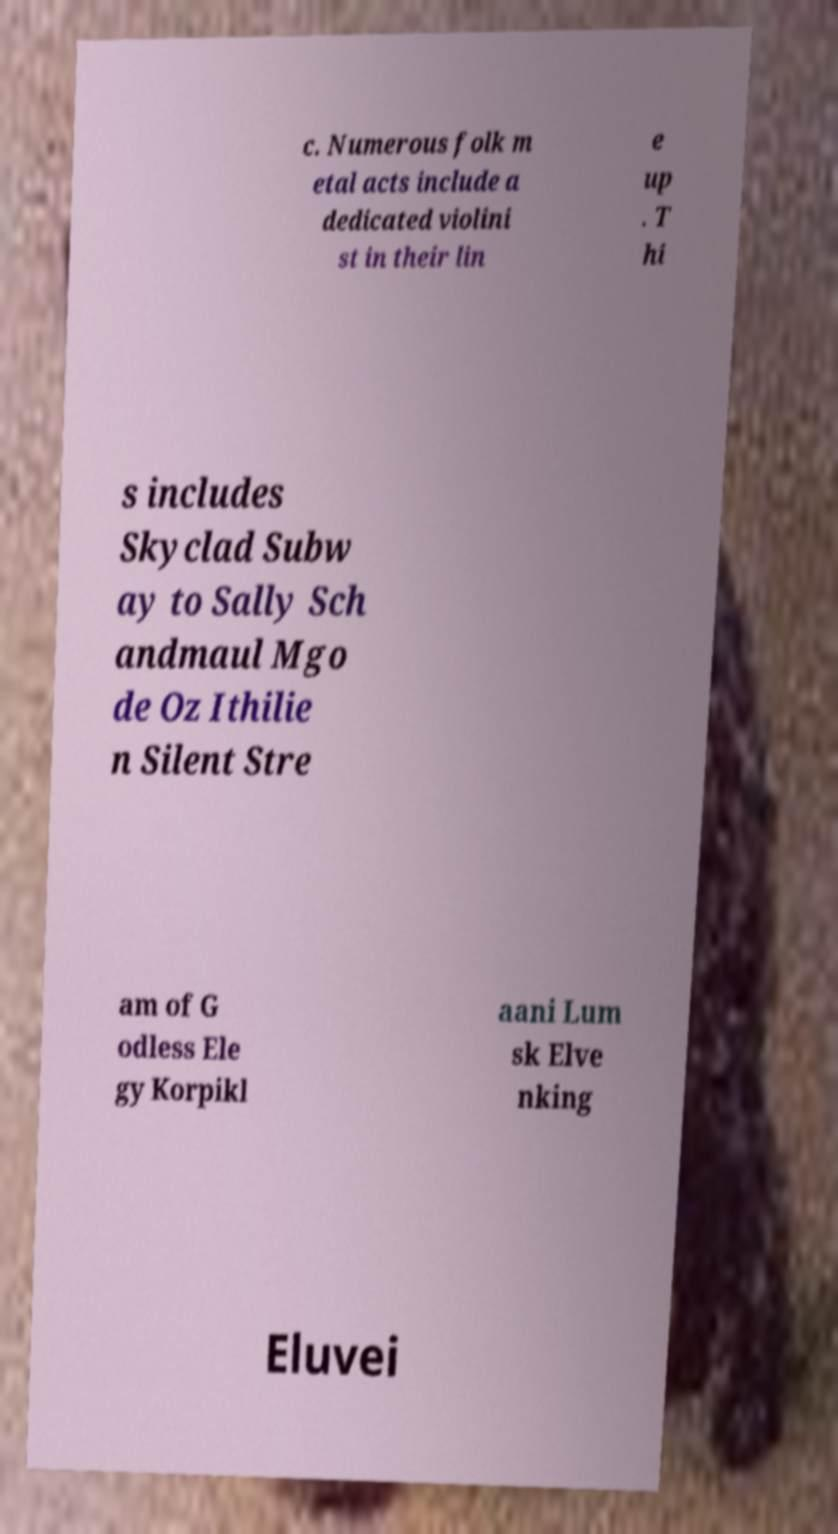I need the written content from this picture converted into text. Can you do that? c. Numerous folk m etal acts include a dedicated violini st in their lin e up . T hi s includes Skyclad Subw ay to Sally Sch andmaul Mgo de Oz Ithilie n Silent Stre am of G odless Ele gy Korpikl aani Lum sk Elve nking Eluvei 